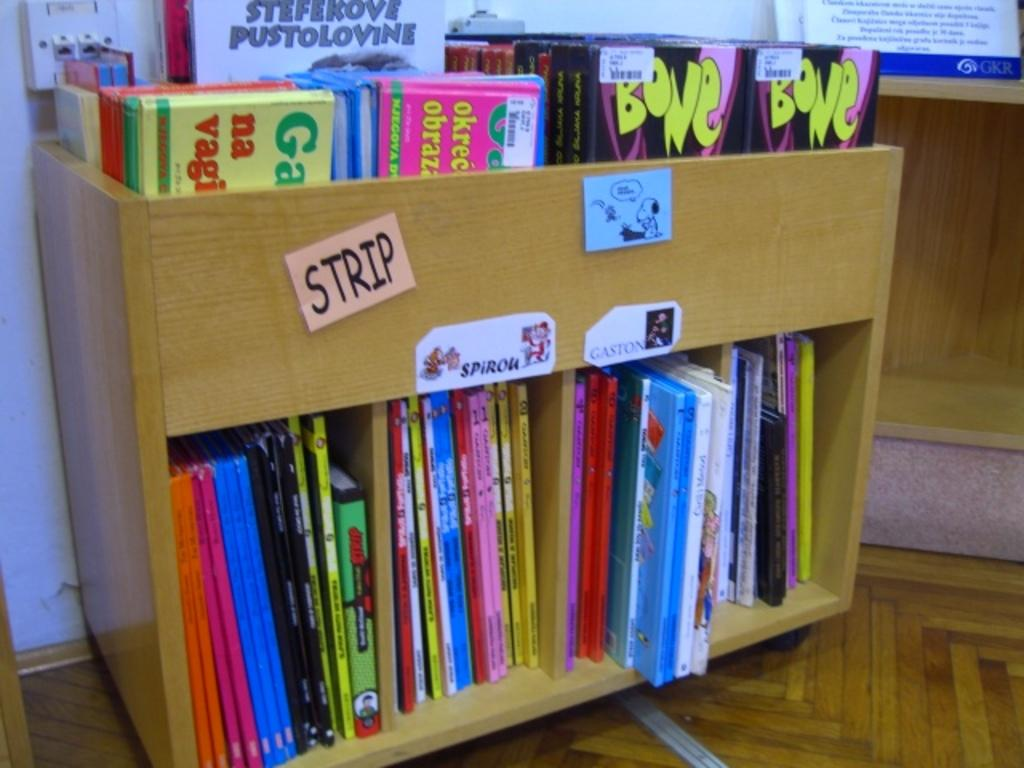Provide a one-sentence caption for the provided image. A wooden cart full of children's books including one called Bone. 